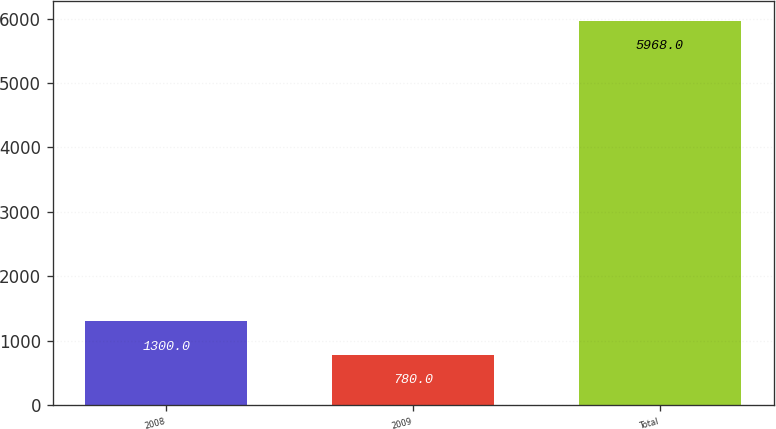Convert chart. <chart><loc_0><loc_0><loc_500><loc_500><bar_chart><fcel>2008<fcel>2009<fcel>Total<nl><fcel>1300<fcel>780<fcel>5968<nl></chart> 